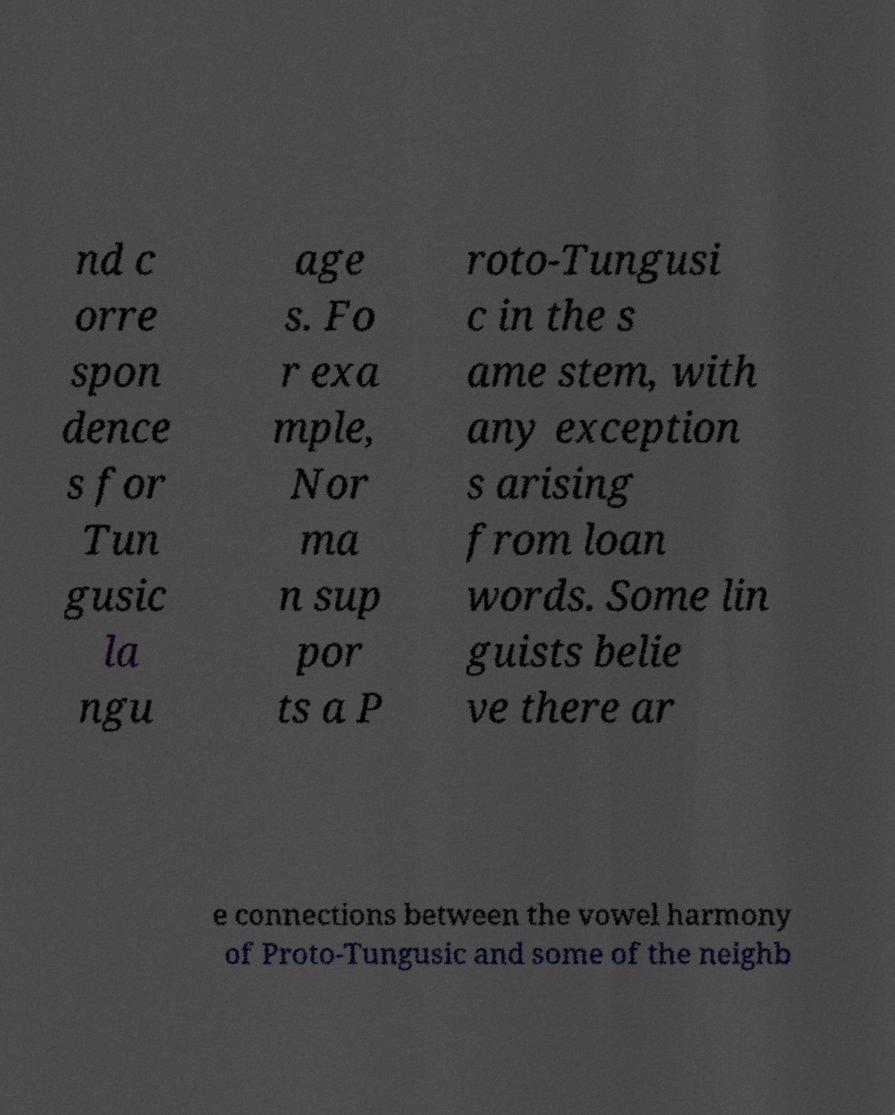Please identify and transcribe the text found in this image. nd c orre spon dence s for Tun gusic la ngu age s. Fo r exa mple, Nor ma n sup por ts a P roto-Tungusi c in the s ame stem, with any exception s arising from loan words. Some lin guists belie ve there ar e connections between the vowel harmony of Proto-Tungusic and some of the neighb 